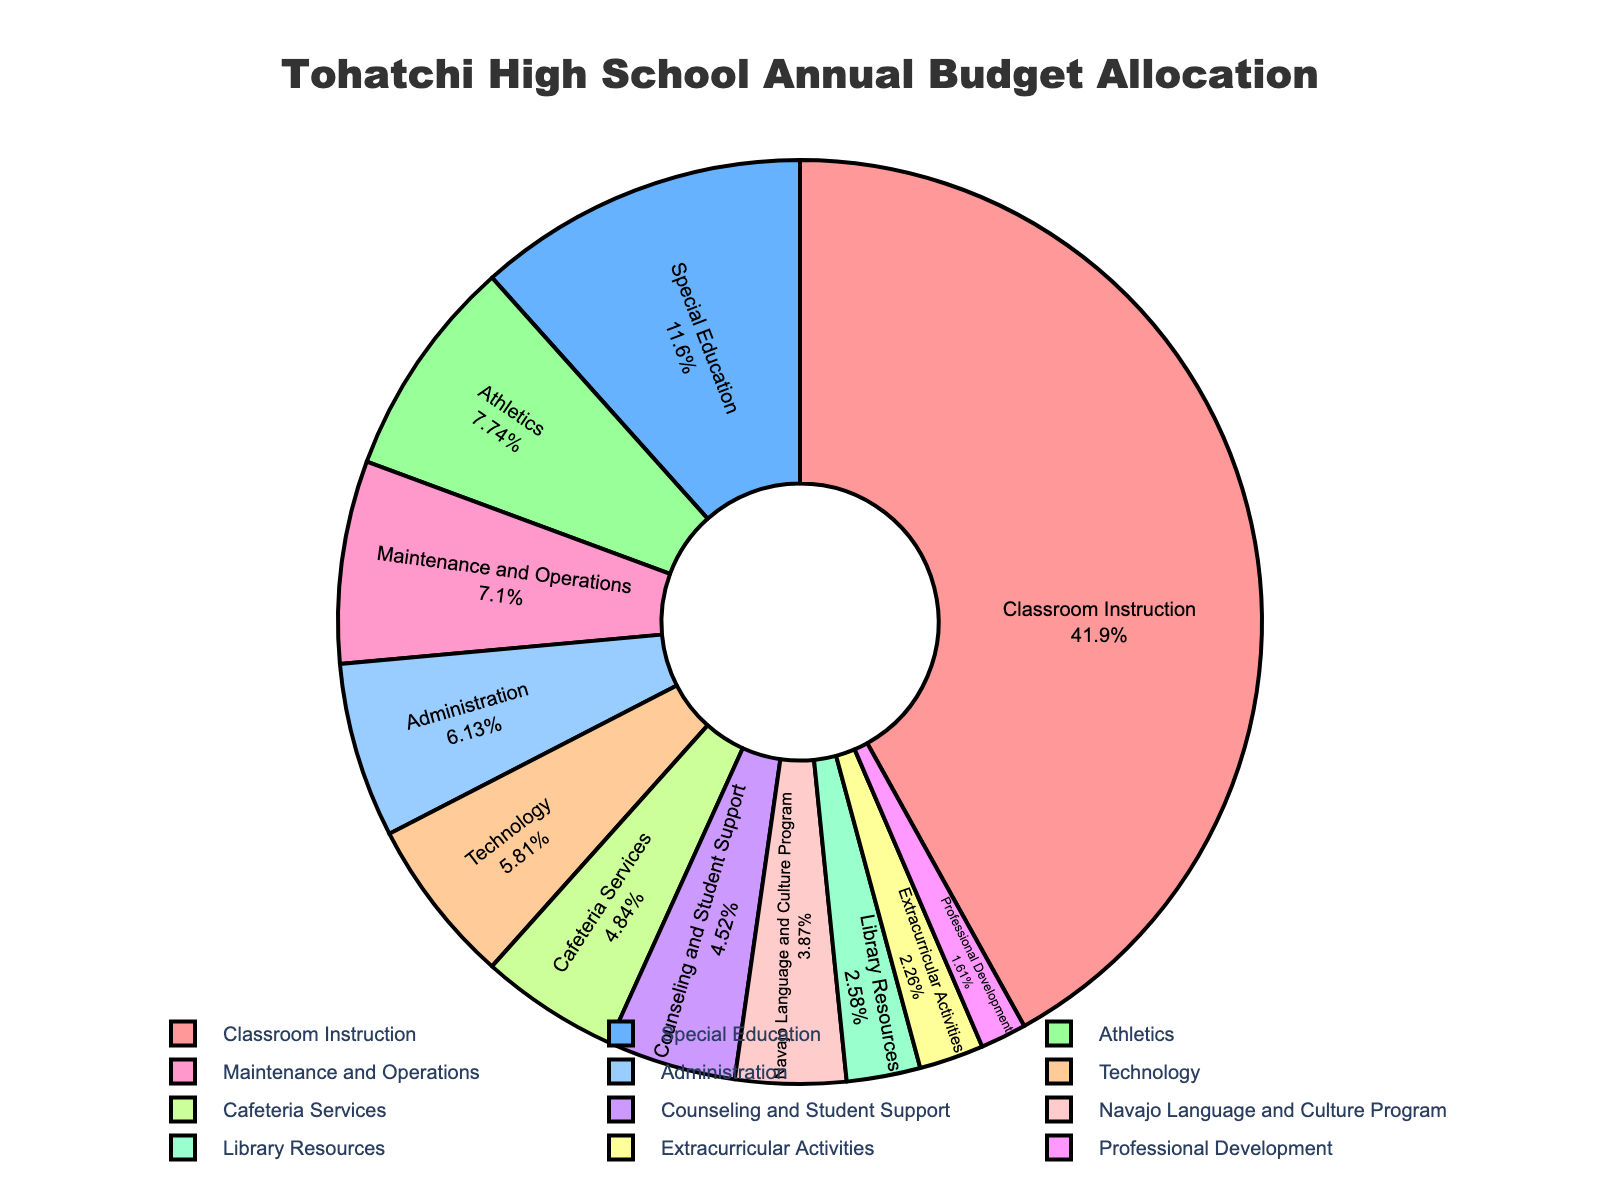what is the total budget allocation for Athletics and Extracurricular Activities combined? First, locate the budget allocations for Athletics ($120,000) and Extracurricular Activities ($35,000). Sum these allocations: $120,000 + $35,000 = $155,000
Answer: $155,000 which department or program has the smallest budget allocation? Identify the smallest value from the budget allocations listed. The smallest value is $25,000, which belongs to Professional Development
Answer: Professional Development How does the budget for Classroom Instruction compare to the combined budget for Library Resources and Counseling and Student Support? The budget for Classroom Instruction is $650,000. The combined budget for Library Resources and Counseling and Student Support is $40,000 + $70,000 = $110,000. Classroom Instruction has a higher budget: $650,000 vs. $110,000
Answer: Classroom Instruction has a higher budget what is the average budget allocation for Administration, Cafeteria Services, and Technology? Sum the budget allocations for Administration ($95,000), Cafeteria Services ($75,000), and Technology ($90,000): $95,000 + $75,000 + $90,000 = $260,000. Divide by the number of departments (3) to get the average: $260,000 / 3 ≈ $86,667
Answer: $86,667 what percentage of the total budget is allocated to Special Education? The total budget is the sum of all allocations: $650,000 + $180,000 + $120,000 + $90,000 + $110,000 + $95,000 + $75,000 + $60,000 + $70,000 + $40,000 + $35,000 + $25,000 = $1,550,000. The percentage for Special Education is ($180,000 / $1,550,000) * 100 ≈ 11.61%
Answer: ~11.61% By how much does the budget of Technology exceed the budget of Library Resources? The budget for Technology is $90,000 and for Library Resources is $40,000. The difference is $90,000 - $40,000 = $50,000
Answer: $50,000 If each department's budget increased by 10%, what would be the new budget for Maintenance and Operations? First, find 10% of Maintenance and Operations' budget: 10% of $110,000 = $11,000. Add this to the original budget: $110,000 + $11,000 = $121,000
Answer: $121,000 